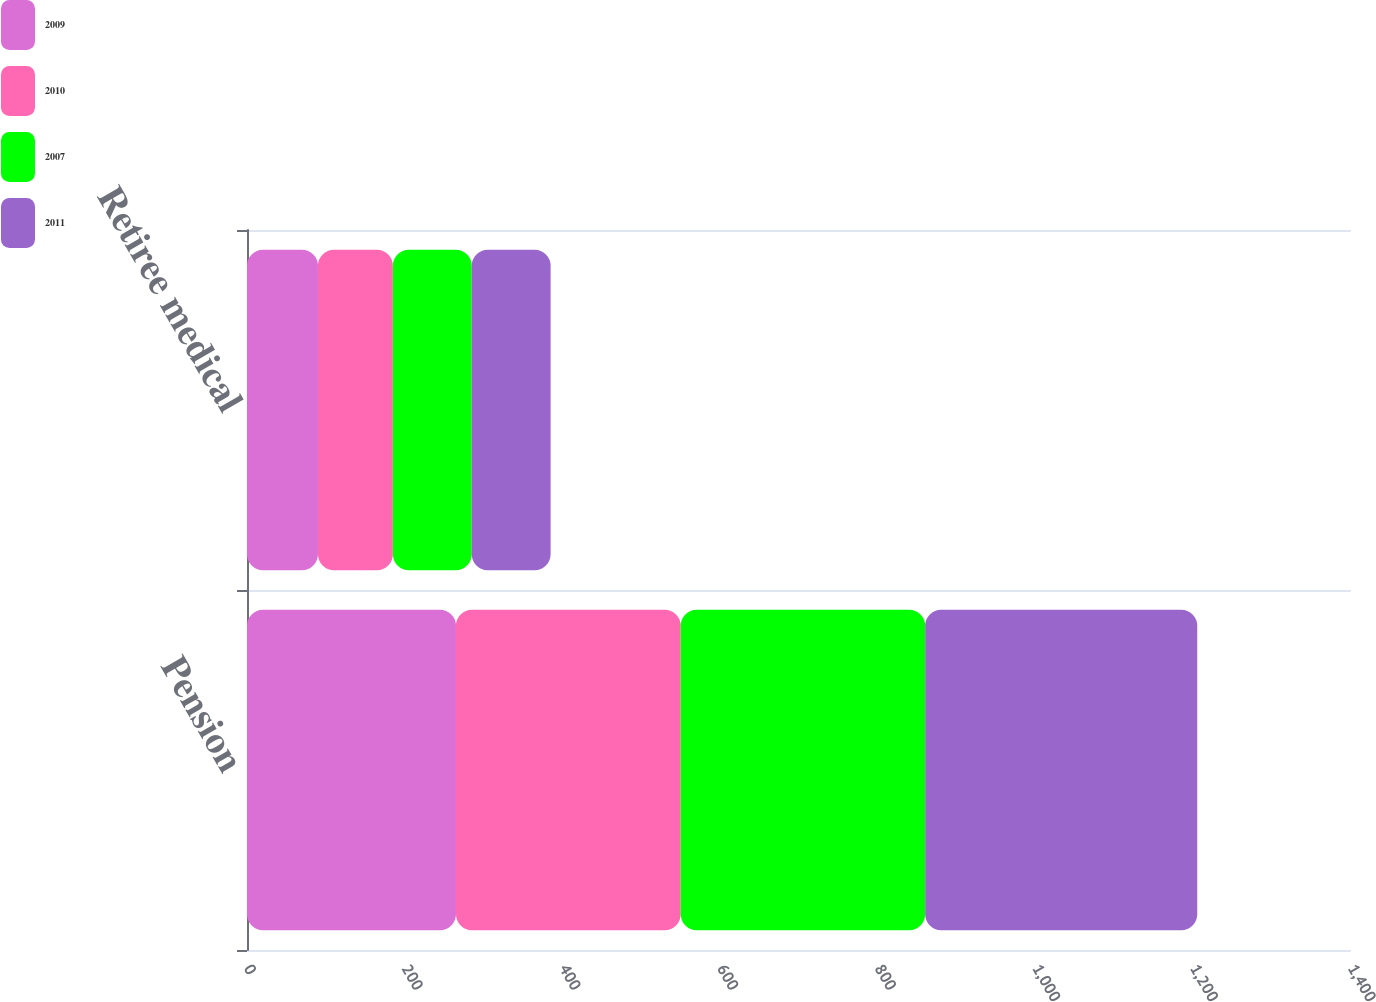Convert chart to OTSL. <chart><loc_0><loc_0><loc_500><loc_500><stacked_bar_chart><ecel><fcel>Pension<fcel>Retiree medical<nl><fcel>2009<fcel>265<fcel>90<nl><fcel>2010<fcel>285<fcel>95<nl><fcel>2007<fcel>310<fcel>100<nl><fcel>2011<fcel>345<fcel>100<nl></chart> 